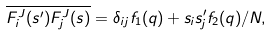Convert formula to latex. <formula><loc_0><loc_0><loc_500><loc_500>\overline { F ^ { J } _ { i } ( { s ^ { \prime } } ) F ^ { J } _ { j } ( { s } ) } = \delta _ { i j } f _ { 1 } ( q ) + s _ { i } s ^ { \prime } _ { j } f _ { 2 } ( q ) / N ,</formula> 